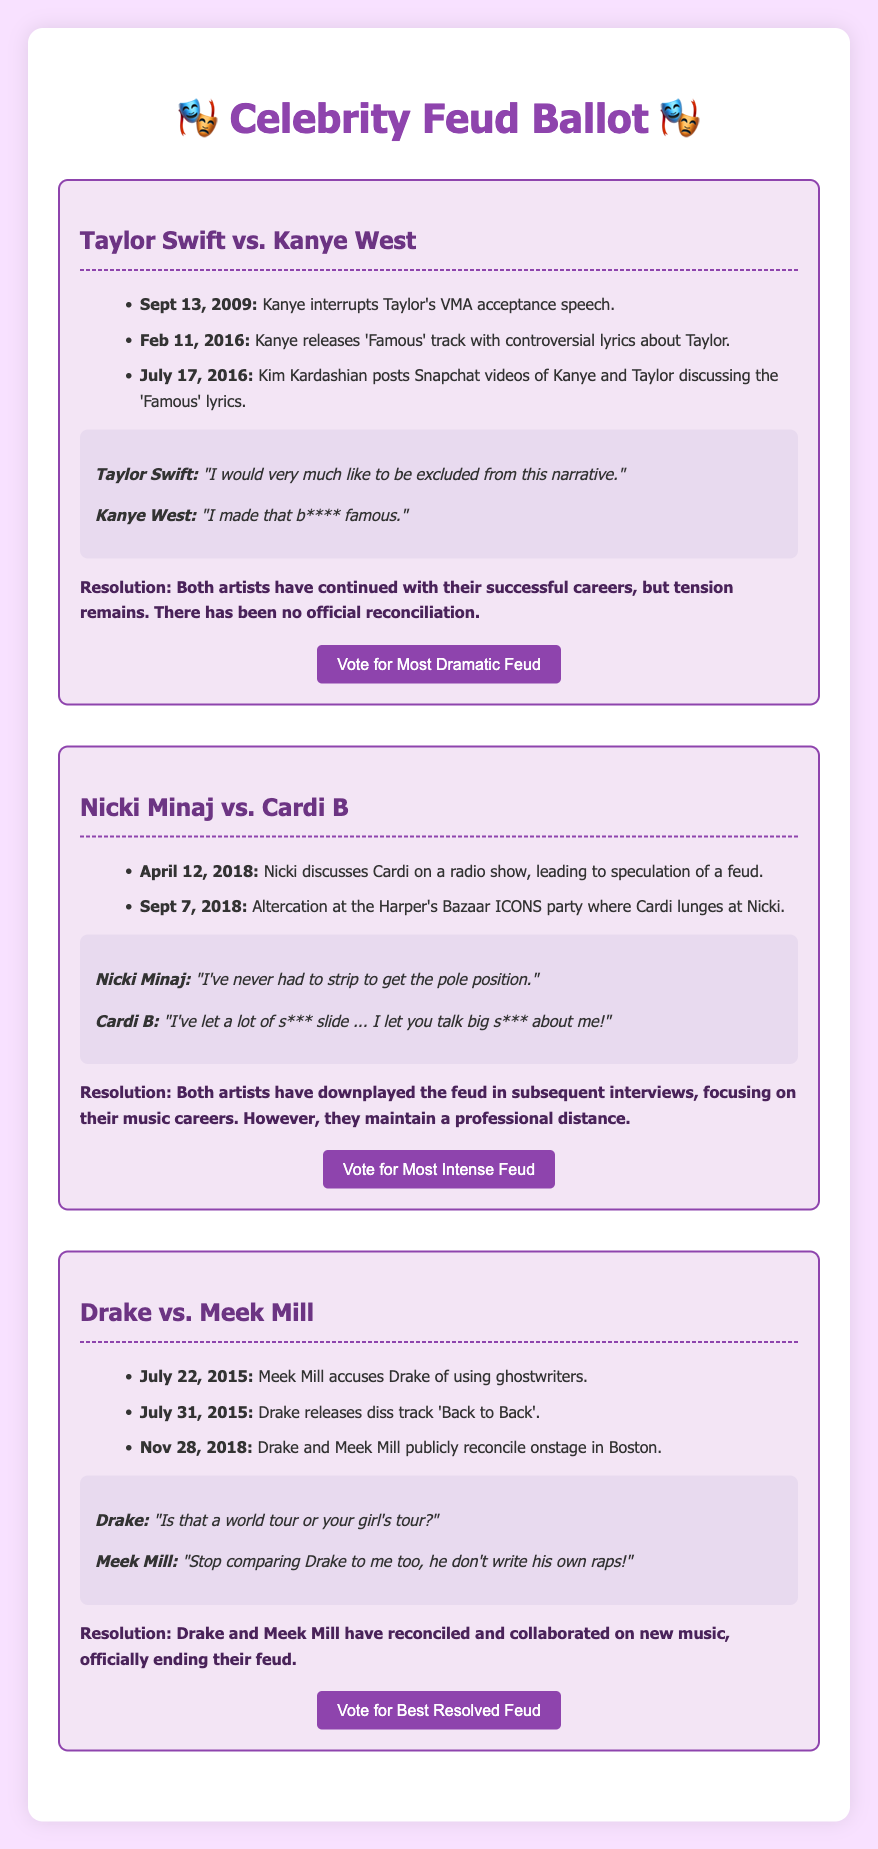What event marked the beginning of the feud between Taylor Swift and Kanye West? The feud started when Kanye interrupted Taylor's VMA acceptance speech.
Answer: Kanye interrupts Taylor's VMA acceptance speech When did Nicki Minaj and Cardi B have their altercation? It occurred at the Harper's Bazaar ICONS party on September 7, 2018.
Answer: Sept 7, 2018 What song did Drake release in response to Meek Mill's accusations? The song released was "Back to Back."
Answer: "Back to Back" What is the resolution outcome of the feud between Drake and Meek Mill? They have reconciled and collaborated on new music.
Answer: Reconciled and collaborated on new music What controversial statement did Kanye West make regarding Taylor Swift? He said, "I made that b**** famous."
Answer: "I made that b**** famous." Which feud involved the phrase "I've never had to strip to get the pole position"? This phrase was used by Nicki Minaj in her feud with Cardi B.
Answer: Nicki Minaj vs. Cardi B What significant date is associated with Kanye West's "Famous" track release? The track was released on February 11, 2016.
Answer: Feb 11, 2016 How did Cardi B express her feelings about Nicki Minaj's comments? She said, "I've let a lot of s*** slide."
Answer: "I've let a lot of s*** slide." 